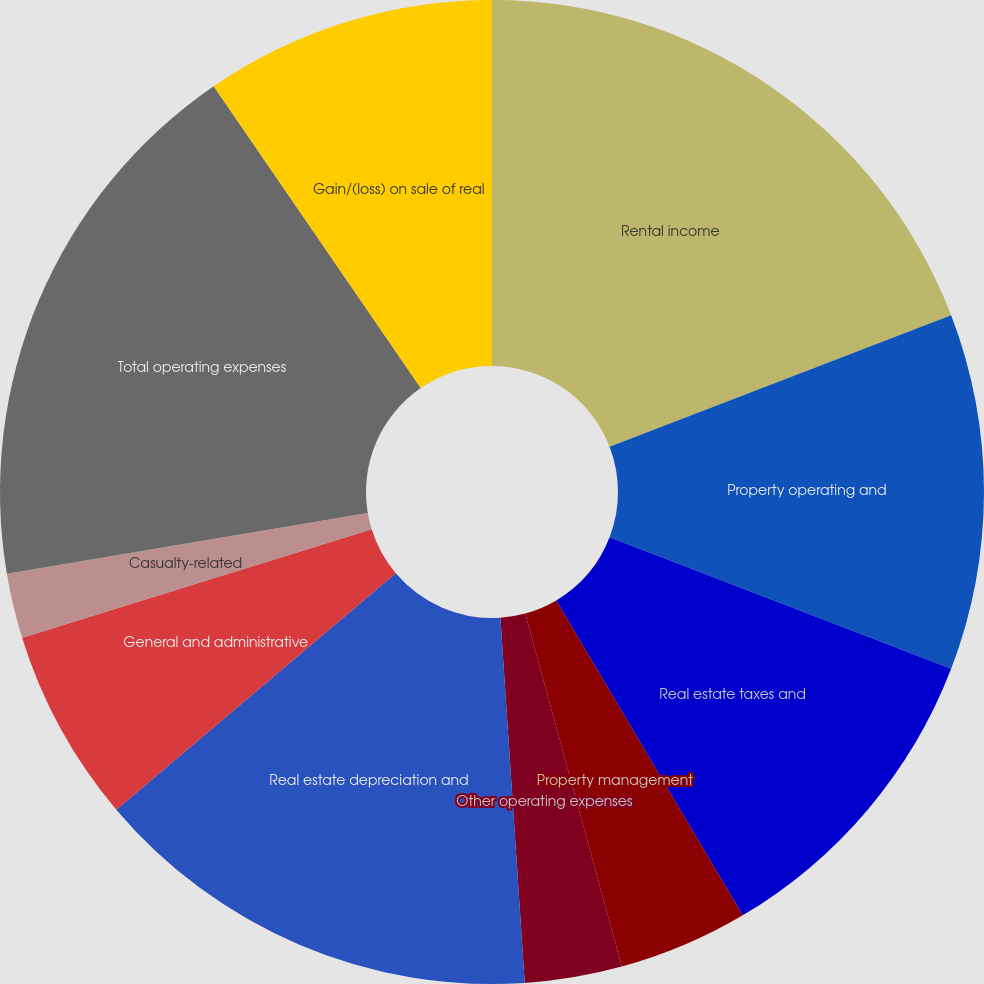Convert chart. <chart><loc_0><loc_0><loc_500><loc_500><pie_chart><fcel>Rental income<fcel>Property operating and<fcel>Real estate taxes and<fcel>Property management<fcel>Other operating expenses<fcel>Real estate depreciation and<fcel>General and administrative<fcel>Casualty-related<fcel>Total operating expenses<fcel>Gain/(loss) on sale of real<nl><fcel>19.15%<fcel>11.7%<fcel>10.64%<fcel>4.26%<fcel>3.19%<fcel>14.89%<fcel>6.38%<fcel>2.13%<fcel>18.09%<fcel>9.57%<nl></chart> 